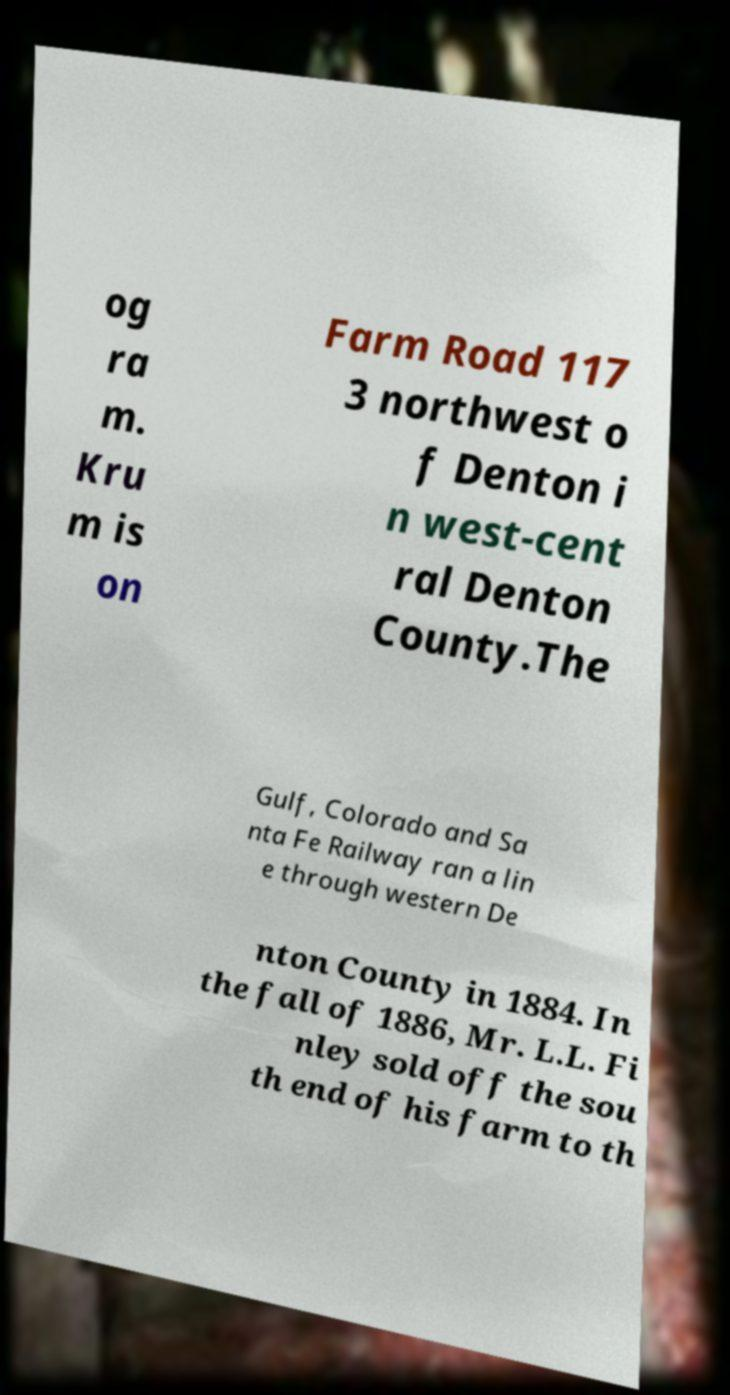Could you assist in decoding the text presented in this image and type it out clearly? og ra m. Kru m is on Farm Road 117 3 northwest o f Denton i n west-cent ral Denton County.The Gulf, Colorado and Sa nta Fe Railway ran a lin e through western De nton County in 1884. In the fall of 1886, Mr. L.L. Fi nley sold off the sou th end of his farm to th 